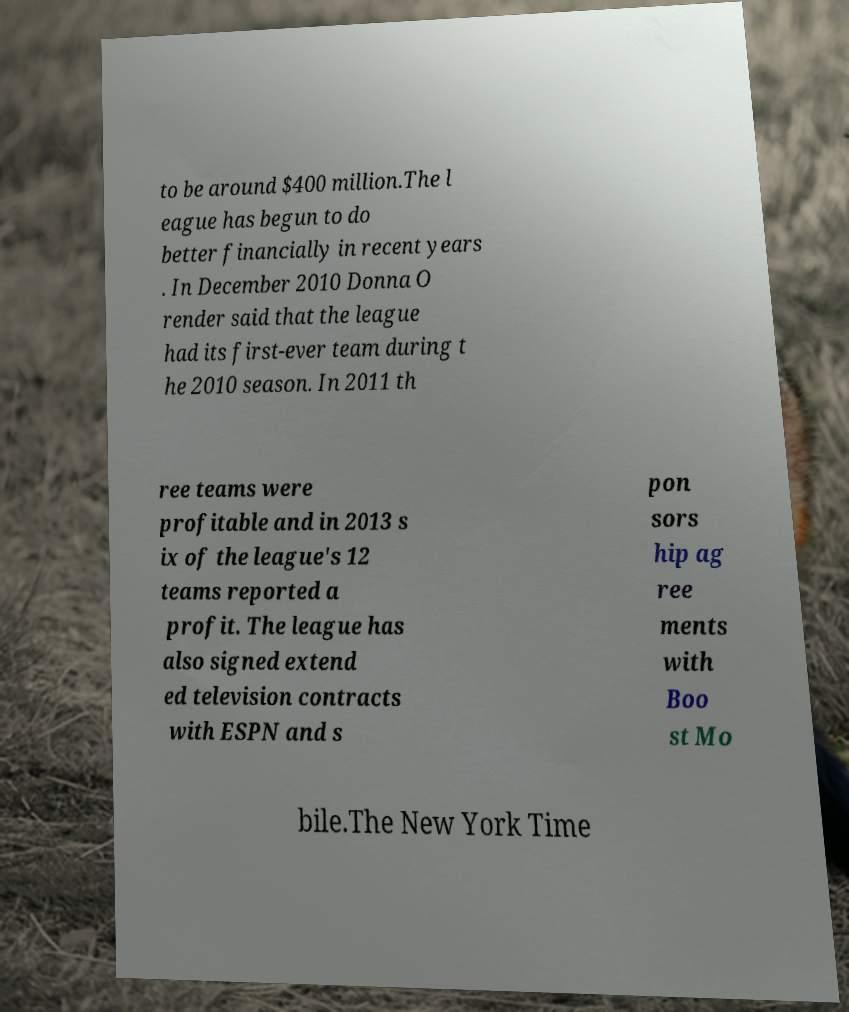Can you read and provide the text displayed in the image?This photo seems to have some interesting text. Can you extract and type it out for me? to be around $400 million.The l eague has begun to do better financially in recent years . In December 2010 Donna O render said that the league had its first-ever team during t he 2010 season. In 2011 th ree teams were profitable and in 2013 s ix of the league's 12 teams reported a profit. The league has also signed extend ed television contracts with ESPN and s pon sors hip ag ree ments with Boo st Mo bile.The New York Time 